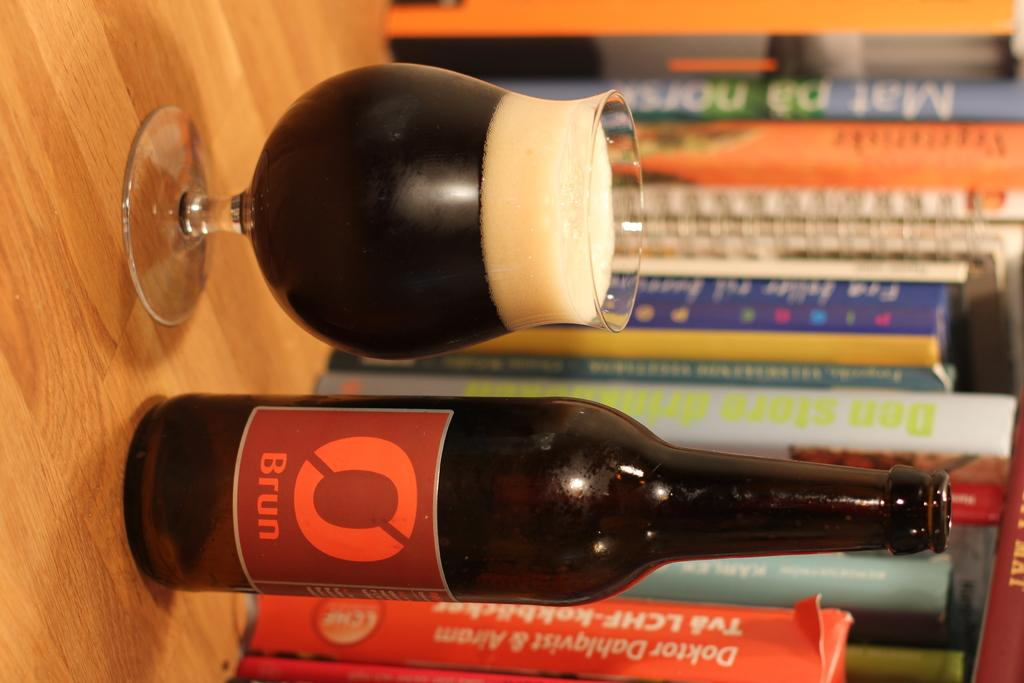<image>
Share a concise interpretation of the image provided. A red label bottle of Brun next to a foaming glass. 